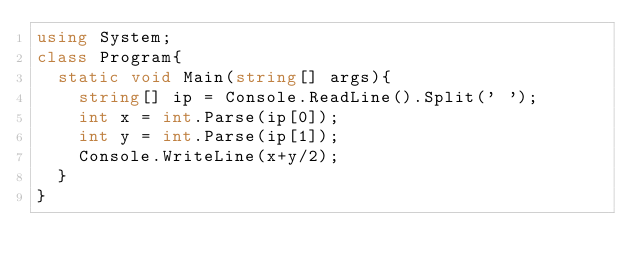<code> <loc_0><loc_0><loc_500><loc_500><_C#_>using System;
class Program{
  static void Main(string[] args){
    string[] ip = Console.ReadLine().Split(' ');
    int x = int.Parse(ip[0]);
    int y = int.Parse(ip[1]);
    Console.WriteLine(x+y/2);
  }
}</code> 